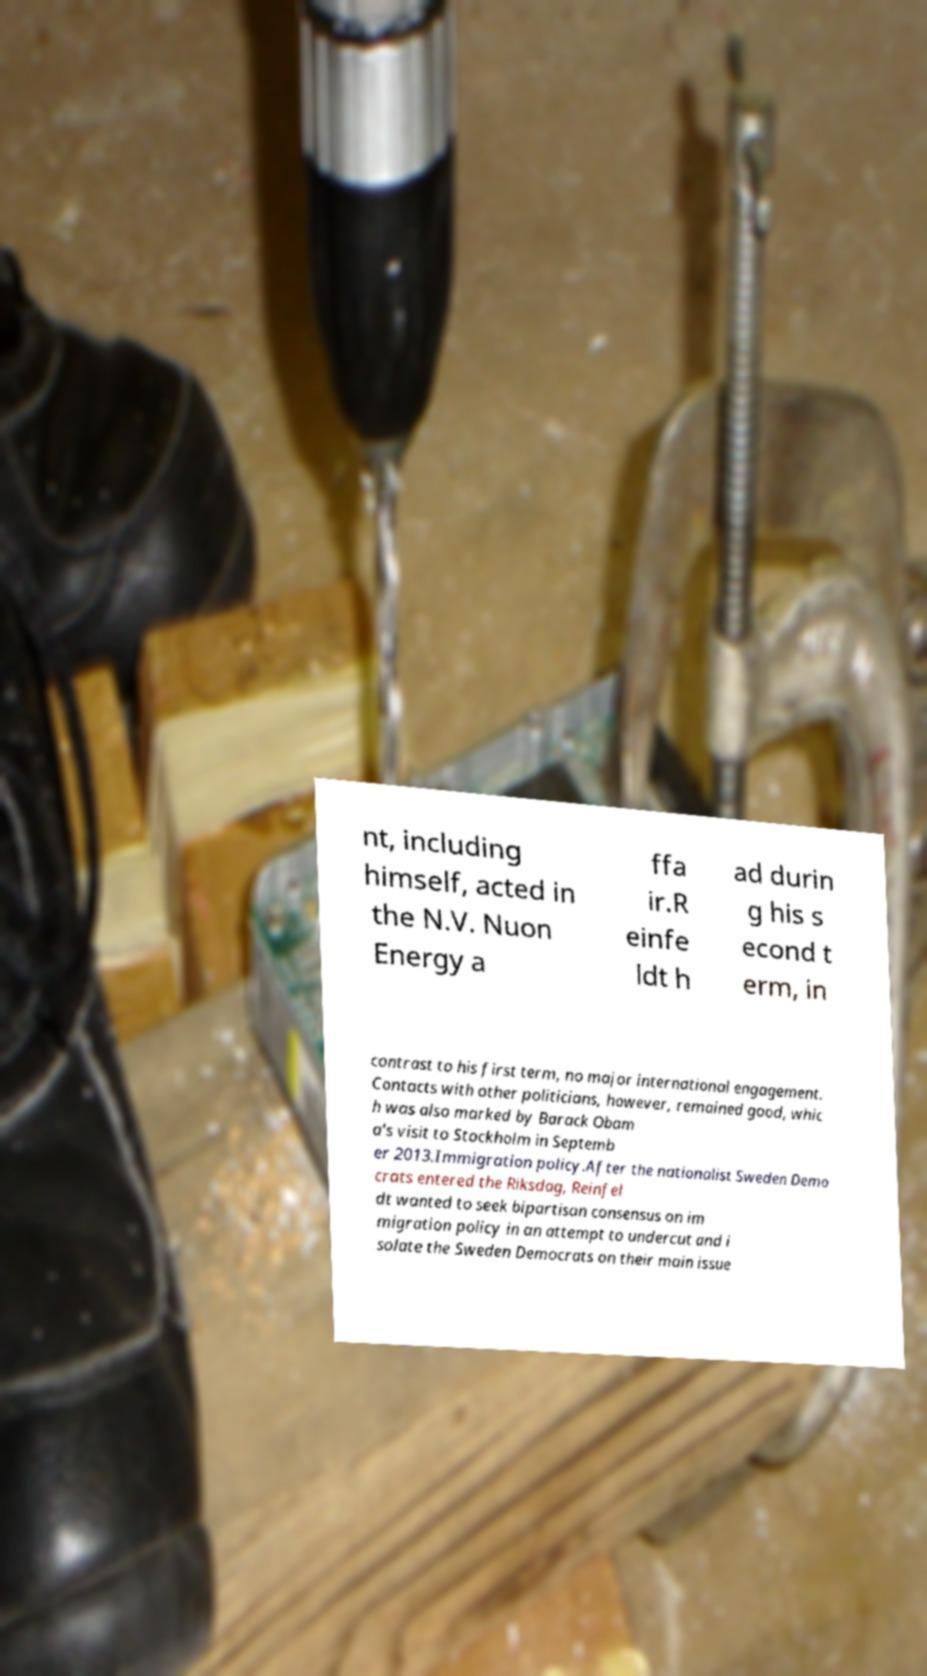Can you read and provide the text displayed in the image?This photo seems to have some interesting text. Can you extract and type it out for me? nt, including himself, acted in the N.V. Nuon Energy a ffa ir.R einfe ldt h ad durin g his s econd t erm, in contrast to his first term, no major international engagement. Contacts with other politicians, however, remained good, whic h was also marked by Barack Obam a's visit to Stockholm in Septemb er 2013.Immigration policy.After the nationalist Sweden Demo crats entered the Riksdag, Reinfel dt wanted to seek bipartisan consensus on im migration policy in an attempt to undercut and i solate the Sweden Democrats on their main issue 